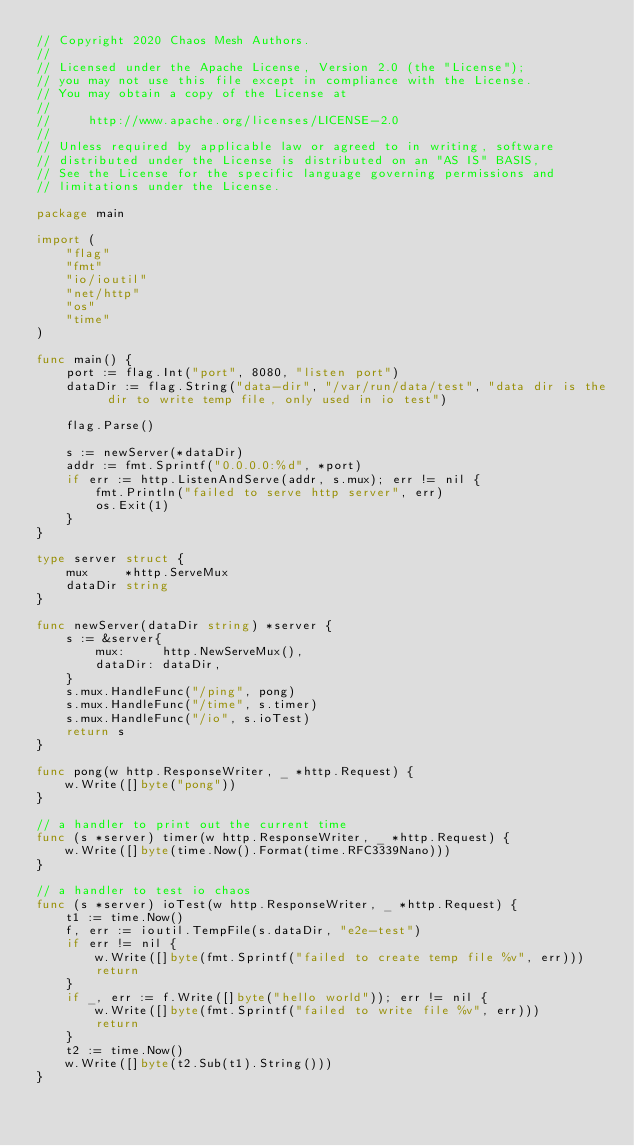Convert code to text. <code><loc_0><loc_0><loc_500><loc_500><_Go_>// Copyright 2020 Chaos Mesh Authors.
//
// Licensed under the Apache License, Version 2.0 (the "License");
// you may not use this file except in compliance with the License.
// You may obtain a copy of the License at
//
//     http://www.apache.org/licenses/LICENSE-2.0
//
// Unless required by applicable law or agreed to in writing, software
// distributed under the License is distributed on an "AS IS" BASIS,
// See the License for the specific language governing permissions and
// limitations under the License.

package main

import (
	"flag"
	"fmt"
	"io/ioutil"
	"net/http"
	"os"
	"time"
)

func main() {
	port := flag.Int("port", 8080, "listen port")
	dataDir := flag.String("data-dir", "/var/run/data/test", "data dir is the dir to write temp file, only used in io test")

	flag.Parse()

	s := newServer(*dataDir)
	addr := fmt.Sprintf("0.0.0.0:%d", *port)
	if err := http.ListenAndServe(addr, s.mux); err != nil {
		fmt.Println("failed to serve http server", err)
		os.Exit(1)
	}
}

type server struct {
	mux     *http.ServeMux
	dataDir string
}

func newServer(dataDir string) *server {
	s := &server{
		mux:     http.NewServeMux(),
		dataDir: dataDir,
	}
	s.mux.HandleFunc("/ping", pong)
	s.mux.HandleFunc("/time", s.timer)
	s.mux.HandleFunc("/io", s.ioTest)
	return s
}

func pong(w http.ResponseWriter, _ *http.Request) {
	w.Write([]byte("pong"))
}

// a handler to print out the current time
func (s *server) timer(w http.ResponseWriter, _ *http.Request) {
	w.Write([]byte(time.Now().Format(time.RFC3339Nano)))
}

// a handler to test io chaos
func (s *server) ioTest(w http.ResponseWriter, _ *http.Request) {
	t1 := time.Now()
	f, err := ioutil.TempFile(s.dataDir, "e2e-test")
	if err != nil {
		w.Write([]byte(fmt.Sprintf("failed to create temp file %v", err)))
		return
	}
	if _, err := f.Write([]byte("hello world")); err != nil {
		w.Write([]byte(fmt.Sprintf("failed to write file %v", err)))
		return
	}
	t2 := time.Now()
	w.Write([]byte(t2.Sub(t1).String()))
}
</code> 